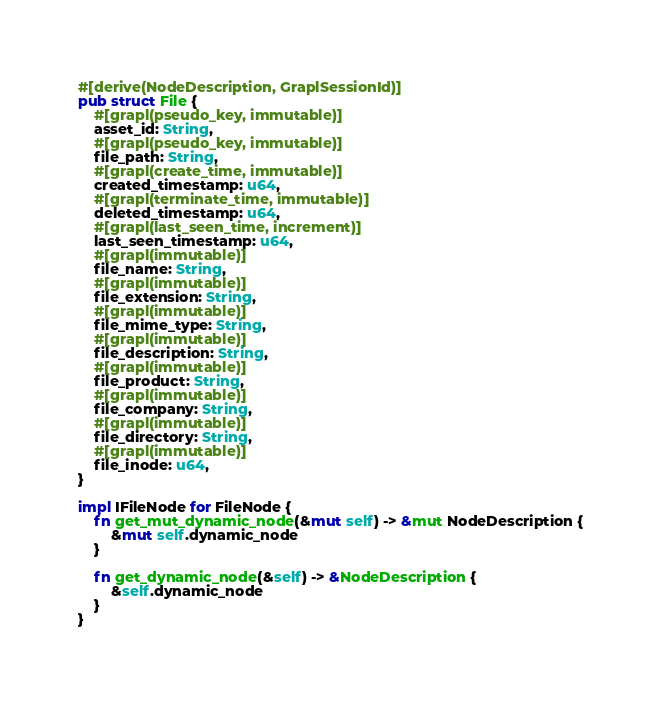<code> <loc_0><loc_0><loc_500><loc_500><_Rust_>
#[derive(NodeDescription, GraplSessionId)]
pub struct File {
    #[grapl(pseudo_key, immutable)]
    asset_id: String,
    #[grapl(pseudo_key, immutable)]
    file_path: String,
    #[grapl(create_time, immutable)]
    created_timestamp: u64,
    #[grapl(terminate_time, immutable)]
    deleted_timestamp: u64,
    #[grapl(last_seen_time, increment)]
    last_seen_timestamp: u64,
    #[grapl(immutable)]
    file_name: String,
    #[grapl(immutable)]
    file_extension: String,
    #[grapl(immutable)]
    file_mime_type: String,
    #[grapl(immutable)]
    file_description: String,
    #[grapl(immutable)]
    file_product: String,
    #[grapl(immutable)]
    file_company: String,
    #[grapl(immutable)]
    file_directory: String,
    #[grapl(immutable)]
    file_inode: u64,
}

impl IFileNode for FileNode {
    fn get_mut_dynamic_node(&mut self) -> &mut NodeDescription {
        &mut self.dynamic_node
    }

    fn get_dynamic_node(&self) -> &NodeDescription {
        &self.dynamic_node
    }
}
</code> 